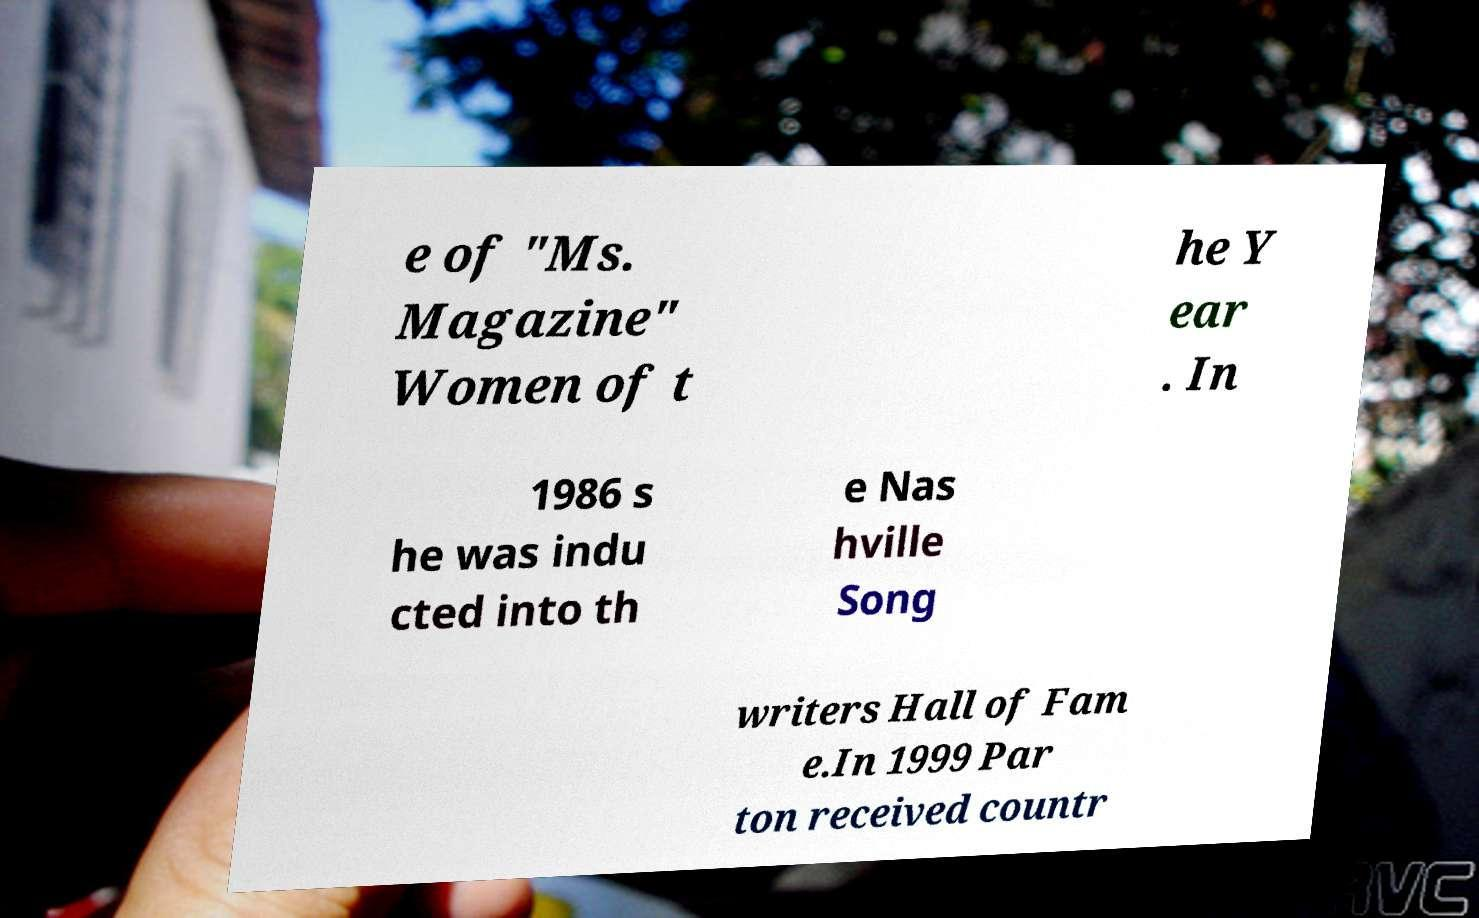Can you read and provide the text displayed in the image?This photo seems to have some interesting text. Can you extract and type it out for me? e of "Ms. Magazine" Women of t he Y ear . In 1986 s he was indu cted into th e Nas hville Song writers Hall of Fam e.In 1999 Par ton received countr 